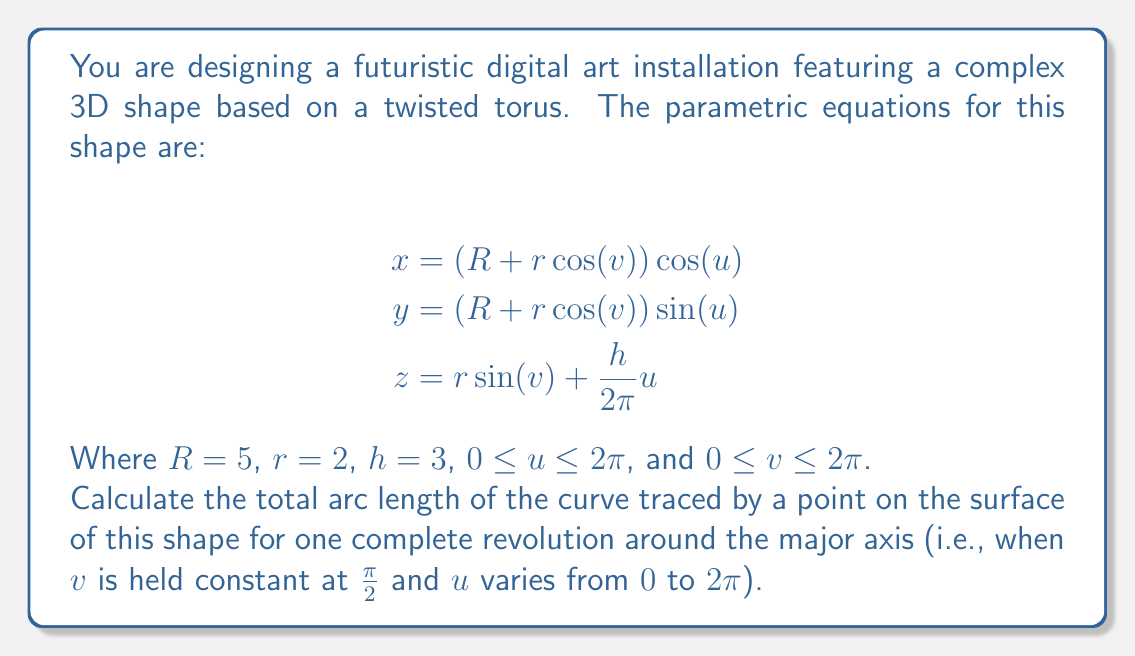Solve this math problem. To solve this problem, we'll follow these steps:

1) First, we need to simplify our equations by setting $v = \frac{\pi}{2}$:

   $$\begin{align*}
   x &= (5 + 2\cos(\frac{\pi}{2}))\cos(u) = 5\cos(u) \\
   y &= (5 + 2\cos(\frac{\pi}{2}))\sin(u) = 5\sin(u) \\
   z &= 2\sin(\frac{\pi}{2}) + \frac{3}{2\pi}u = 2 + \frac{3}{2\pi}u
   \end{align*}$$

2) The arc length of a parametric curve is given by the formula:

   $$L = \int_a^b \sqrt{(\frac{dx}{du})^2 + (\frac{dy}{du})^2 + (\frac{dz}{du})^2} du$$

3) Let's calculate the derivatives:

   $$\begin{align*}
   \frac{dx}{du} &= -5\sin(u) \\
   \frac{dy}{du} &= 5\cos(u) \\
   \frac{dz}{du} &= \frac{3}{2\pi}
   \end{align*}$$

4) Substituting these into our arc length formula:

   $$L = \int_0^{2\pi} \sqrt{(-5\sin(u))^2 + (5\cos(u))^2 + (\frac{3}{2\pi})^2} du$$

5) Simplify under the square root:

   $$L = \int_0^{2\pi} \sqrt{25\sin^2(u) + 25\cos^2(u) + (\frac{3}{2\pi})^2} du$$

6) Use the identity $\sin^2(u) + \cos^2(u) = 1$:

   $$L = \int_0^{2\pi} \sqrt{25 + (\frac{3}{2\pi})^2} du$$

7) The expression under the square root is constant, so we can take it out of the integral:

   $$L = \sqrt{25 + (\frac{3}{2\pi})^2} \int_0^{2\pi} du$$

8) Evaluate the integral:

   $$L = \sqrt{25 + (\frac{3}{2\pi})^2} \cdot 2\pi$$

9) Simplify:

   $$L = 2\pi\sqrt{25 + (\frac{3}{2\pi})^2} \approx 31.42$$
Answer: The total arc length of the curve is $2\pi\sqrt{25 + (\frac{3}{2\pi})^2}$ units, which is approximately 31.42 units. 